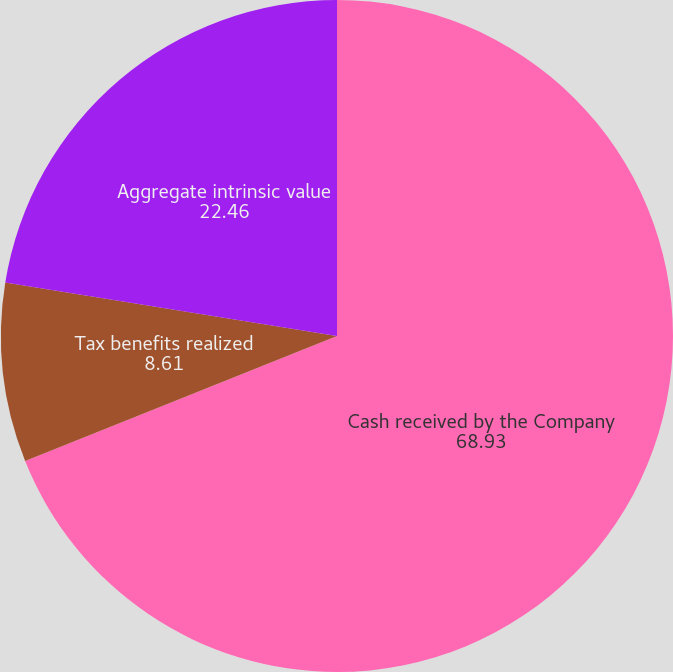Convert chart. <chart><loc_0><loc_0><loc_500><loc_500><pie_chart><fcel>Cash received by the Company<fcel>Tax benefits realized<fcel>Aggregate intrinsic value<nl><fcel>68.93%<fcel>8.61%<fcel>22.46%<nl></chart> 